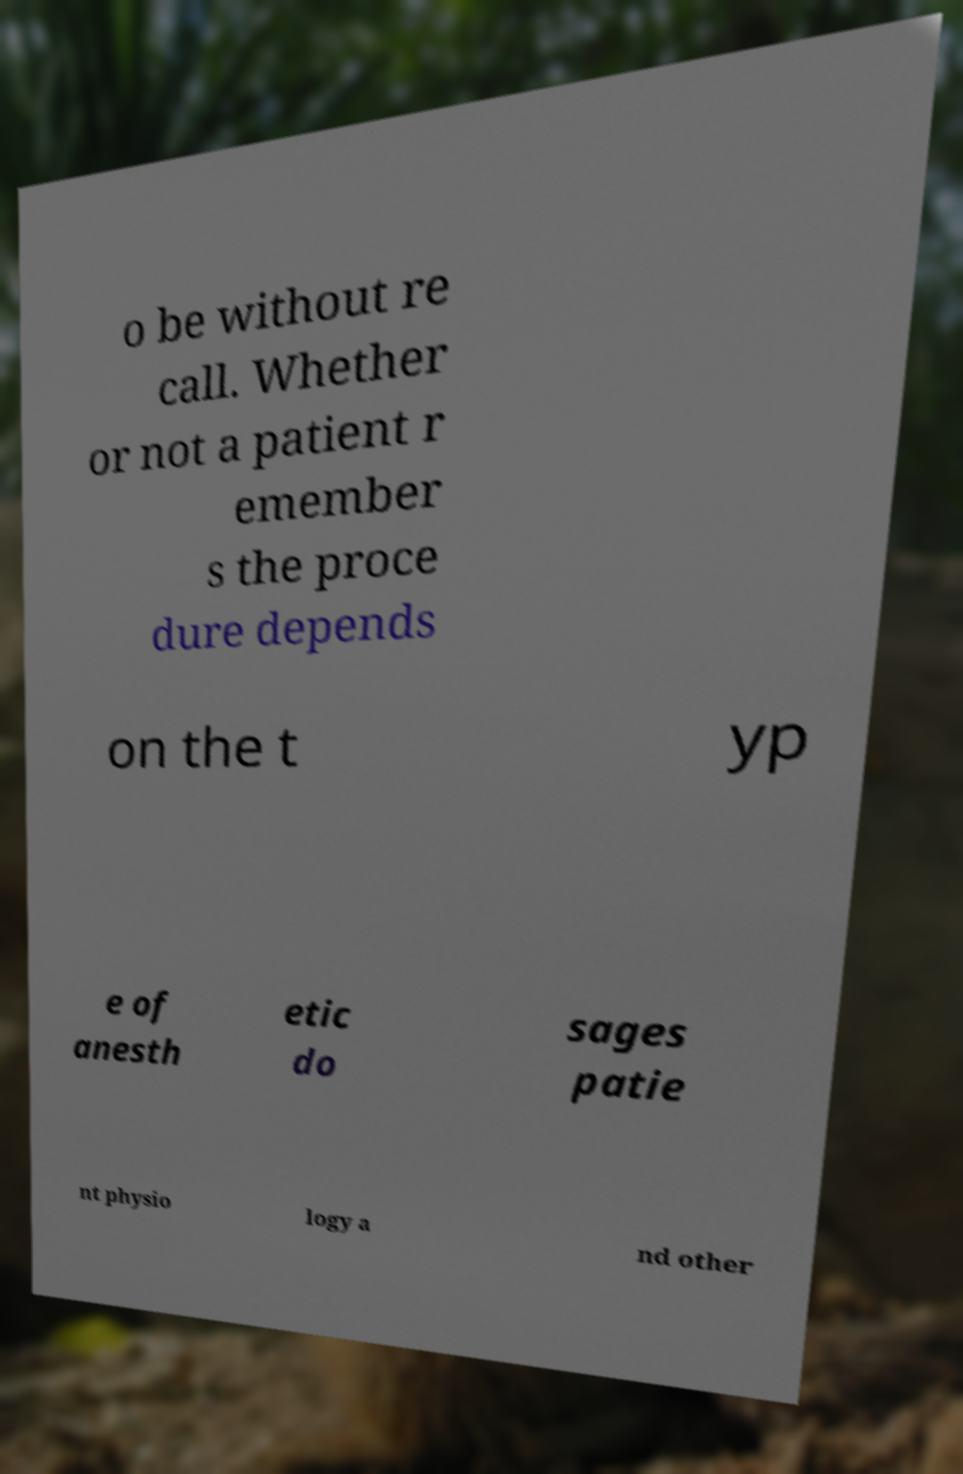Could you extract and type out the text from this image? o be without re call. Whether or not a patient r emember s the proce dure depends on the t yp e of anesth etic do sages patie nt physio logy a nd other 